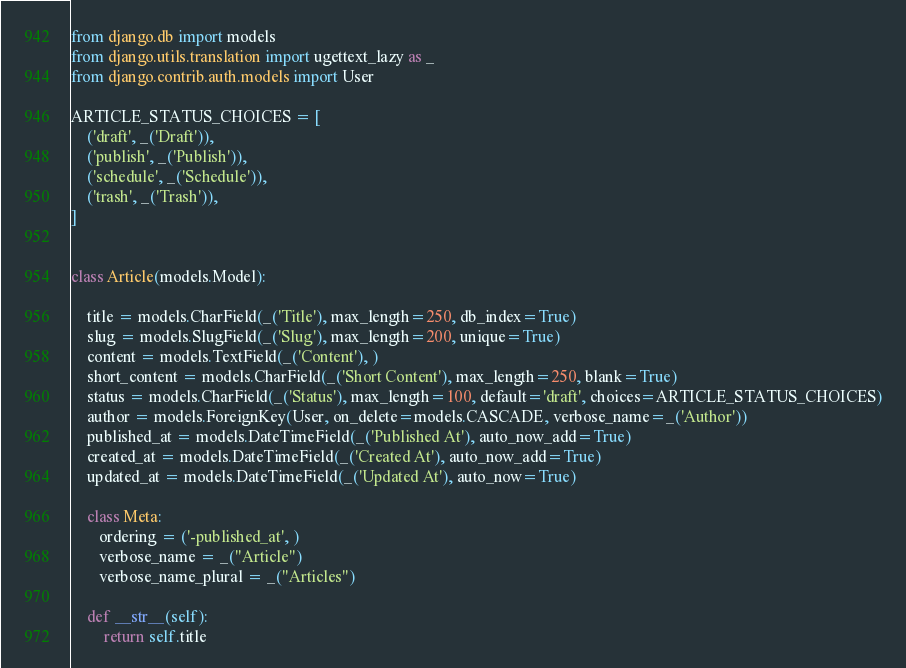<code> <loc_0><loc_0><loc_500><loc_500><_Python_>from django.db import models
from django.utils.translation import ugettext_lazy as _
from django.contrib.auth.models import User

ARTICLE_STATUS_CHOICES = [
    ('draft', _('Draft')),
    ('publish', _('Publish')),
    ('schedule', _('Schedule')),
    ('trash', _('Trash')),
]


class Article(models.Model):

    title = models.CharField(_('Title'), max_length=250, db_index=True)
    slug = models.SlugField(_('Slug'), max_length=200, unique=True)
    content = models.TextField(_('Content'), )
    short_content = models.CharField(_('Short Content'), max_length=250, blank=True)
    status = models.CharField(_('Status'), max_length=100, default='draft', choices=ARTICLE_STATUS_CHOICES)
    author = models.ForeignKey(User, on_delete=models.CASCADE, verbose_name=_('Author'))
    published_at = models.DateTimeField(_('Published At'), auto_now_add=True)
    created_at = models.DateTimeField(_('Created At'), auto_now_add=True)
    updated_at = models.DateTimeField(_('Updated At'), auto_now=True)

    class Meta: 
       ordering = ('-published_at', ) 
       verbose_name = _("Article")
       verbose_name_plural = _("Articles")

    def __str__(self):
        return self.title
</code> 